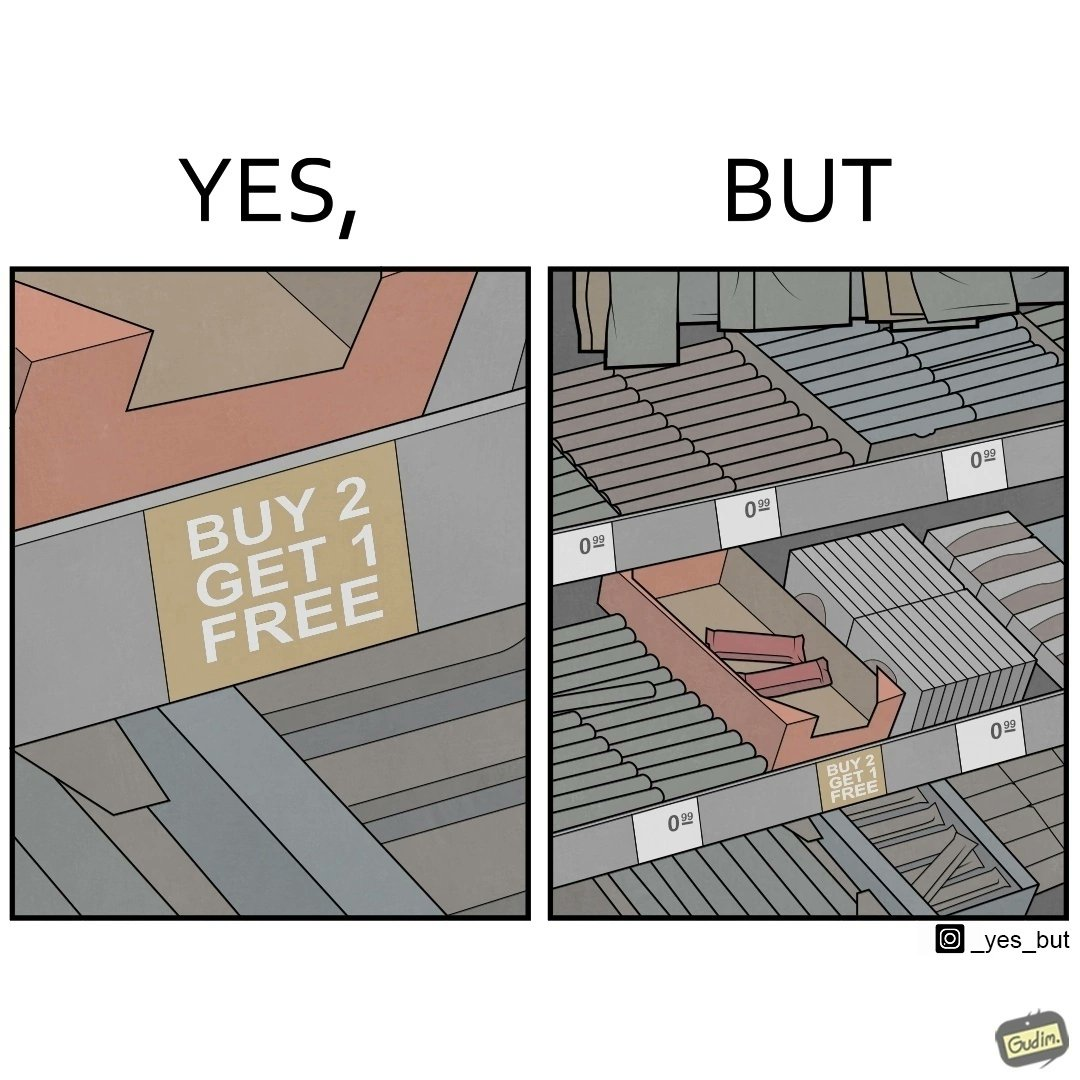Describe the contrast between the left and right parts of this image. In the left part of the image: The image shows a label saying "BUY 2 GET 1 FREE" which means that on a purchase of two unit of this product, the buyer would get one more unit for free. In the right part of the image: The image shows two units of a product that is labelled "BUY 2 GET 1 FREE". 